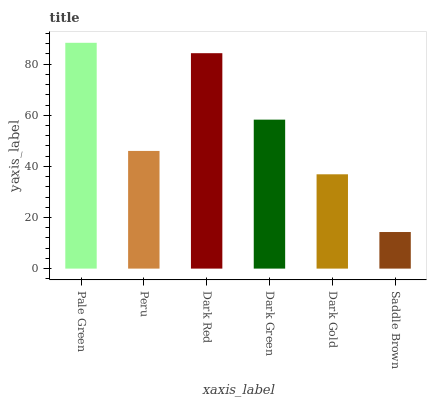Is Peru the minimum?
Answer yes or no. No. Is Peru the maximum?
Answer yes or no. No. Is Pale Green greater than Peru?
Answer yes or no. Yes. Is Peru less than Pale Green?
Answer yes or no. Yes. Is Peru greater than Pale Green?
Answer yes or no. No. Is Pale Green less than Peru?
Answer yes or no. No. Is Dark Green the high median?
Answer yes or no. Yes. Is Peru the low median?
Answer yes or no. Yes. Is Peru the high median?
Answer yes or no. No. Is Pale Green the low median?
Answer yes or no. No. 